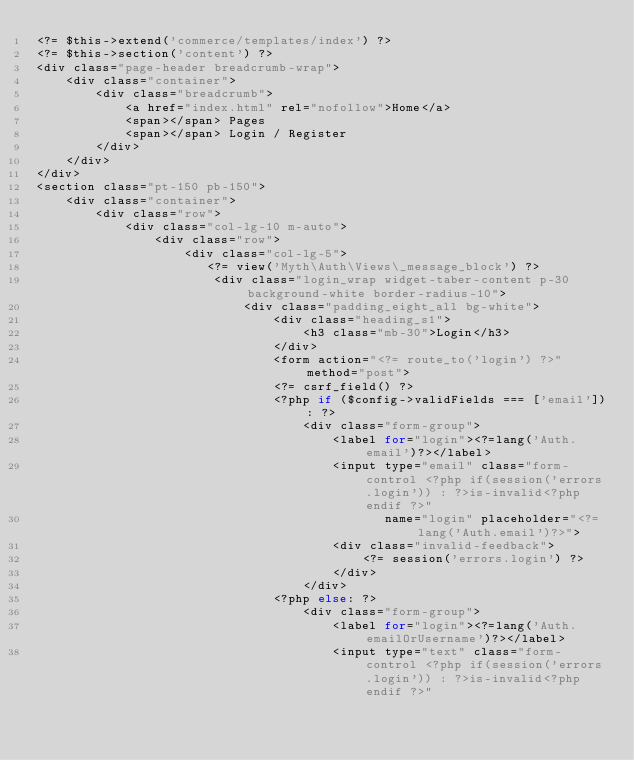<code> <loc_0><loc_0><loc_500><loc_500><_PHP_><?= $this->extend('commerce/templates/index') ?>
<?= $this->section('content') ?>
<div class="page-header breadcrumb-wrap">
    <div class="container">
        <div class="breadcrumb">
            <a href="index.html" rel="nofollow">Home</a>
            <span></span> Pages
            <span></span> Login / Register
        </div>
    </div>
</div>
<section class="pt-150 pb-150">
    <div class="container">
        <div class="row">
            <div class="col-lg-10 m-auto">
                <div class="row">
                    <div class="col-lg-5">
                       <?= view('Myth\Auth\Views\_message_block') ?>
                        <div class="login_wrap widget-taber-content p-30 background-white border-radius-10">
                            <div class="padding_eight_all bg-white">
                                <div class="heading_s1">
                                    <h3 class="mb-30">Login</h3>
                                </div>
                                <form action="<?= route_to('login') ?>" method="post">
                                <?= csrf_field() ?>
                                <?php if ($config->validFields === ['email']): ?>
                                    <div class="form-group">
                                        <label for="login"><?=lang('Auth.email')?></label>
                                        <input type="email" class="form-control <?php if(session('errors.login')) : ?>is-invalid<?php endif ?>"
                                               name="login" placeholder="<?=lang('Auth.email')?>">
                                        <div class="invalid-feedback">
                                            <?= session('errors.login') ?>
                                        </div>
                                    </div>
                                <?php else: ?>
                                    <div class="form-group">
                                        <label for="login"><?=lang('Auth.emailOrUsername')?></label>
                                        <input type="text" class="form-control <?php if(session('errors.login')) : ?>is-invalid<?php endif ?>"</code> 